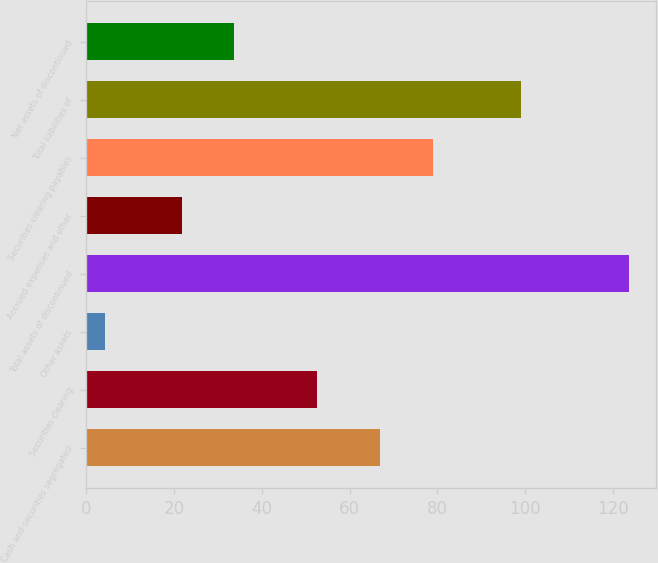<chart> <loc_0><loc_0><loc_500><loc_500><bar_chart><fcel>Cash and securities segregated<fcel>Securities clearing<fcel>Other assets<fcel>Total assets of discontinued<fcel>Accrued expenses and other<fcel>Securities clearing payables<fcel>Total liabilities of<fcel>Net assets of discontinued<nl><fcel>67<fcel>52.5<fcel>4.3<fcel>123.8<fcel>21.7<fcel>78.95<fcel>99.1<fcel>33.65<nl></chart> 